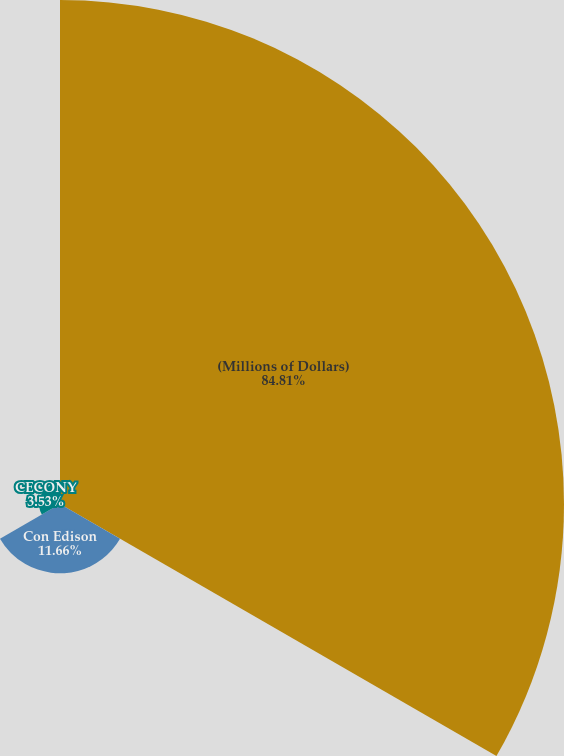Convert chart to OTSL. <chart><loc_0><loc_0><loc_500><loc_500><pie_chart><fcel>(Millions of Dollars)<fcel>Con Edison<fcel>CECONY<nl><fcel>84.81%<fcel>11.66%<fcel>3.53%<nl></chart> 